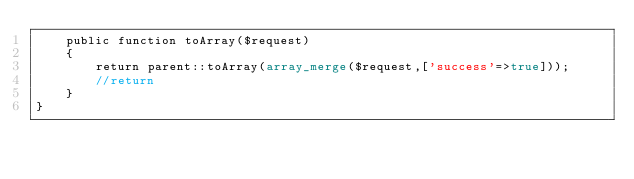Convert code to text. <code><loc_0><loc_0><loc_500><loc_500><_PHP_>    public function toArray($request)
    {
        return parent::toArray(array_merge($request,['success'=>true]));
        //return 
    }
}
</code> 